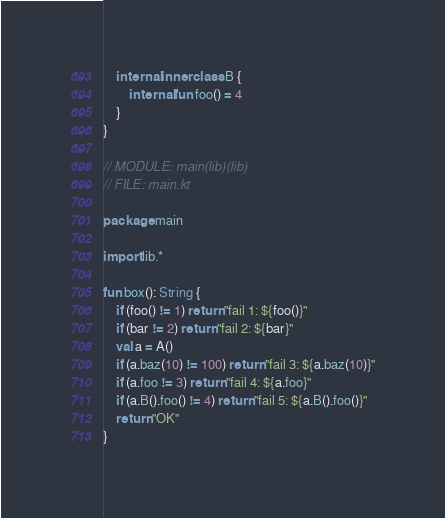Convert code to text. <code><loc_0><loc_0><loc_500><loc_500><_Kotlin_>    internal inner class B {
        internal fun foo() = 4
    }
}

// MODULE: main(lib)(lib)
// FILE: main.kt

package main

import lib.*

fun box(): String {
    if (foo() != 1) return "fail 1: ${foo()}"
    if (bar != 2) return "fail 2: ${bar}"
    val a = A()
    if (a.baz(10) != 100) return "fail 3: ${a.baz(10)}"
    if (a.foo != 3) return "fail 4: ${a.foo}"
    if (a.B().foo() != 4) return "fail 5: ${a.B().foo()}"
    return "OK"
}</code> 